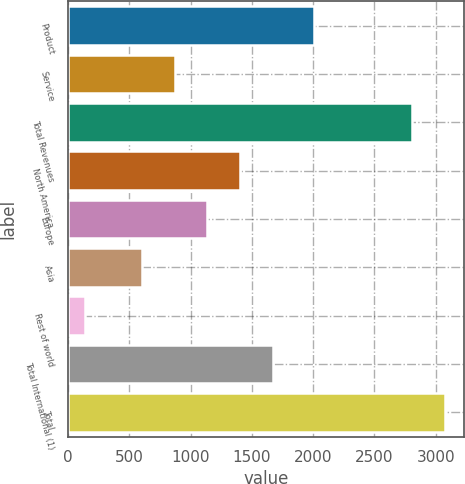<chart> <loc_0><loc_0><loc_500><loc_500><bar_chart><fcel>Product<fcel>Service<fcel>Total Revenues<fcel>North America<fcel>Europe<fcel>Asia<fcel>Rest of world<fcel>Total International (1)<fcel>Total<nl><fcel>2004<fcel>868.7<fcel>2807<fcel>1402.1<fcel>1135.4<fcel>602<fcel>140<fcel>1668.8<fcel>3073.7<nl></chart> 